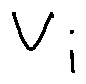<formula> <loc_0><loc_0><loc_500><loc_500>v _ { i }</formula> 